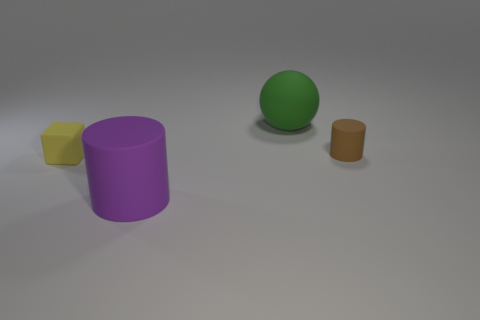What shape is the big thing that is in front of the yellow matte cube?
Provide a short and direct response. Cylinder. What shape is the small thing behind the matte object on the left side of the large purple cylinder?
Offer a terse response. Cylinder. Is there a green rubber object that has the same shape as the small brown matte object?
Provide a succinct answer. No. There is a yellow thing that is the same size as the brown matte cylinder; what is its shape?
Your response must be concise. Cube. There is a small rubber object that is on the left side of the cylinder in front of the small cube; are there any small yellow blocks that are in front of it?
Offer a very short reply. No. Is there a yellow matte thing of the same size as the purple matte thing?
Provide a succinct answer. No. There is a object that is in front of the tiny matte block; what is its size?
Give a very brief answer. Large. There is a cylinder behind the large matte thing that is in front of the rubber thing that is on the right side of the big green thing; what color is it?
Provide a succinct answer. Brown. There is a matte cylinder that is right of the big object that is on the right side of the purple thing; what color is it?
Ensure brevity in your answer.  Brown. Is the number of big things in front of the tiny brown rubber cylinder greater than the number of big purple objects behind the large cylinder?
Give a very brief answer. Yes. 